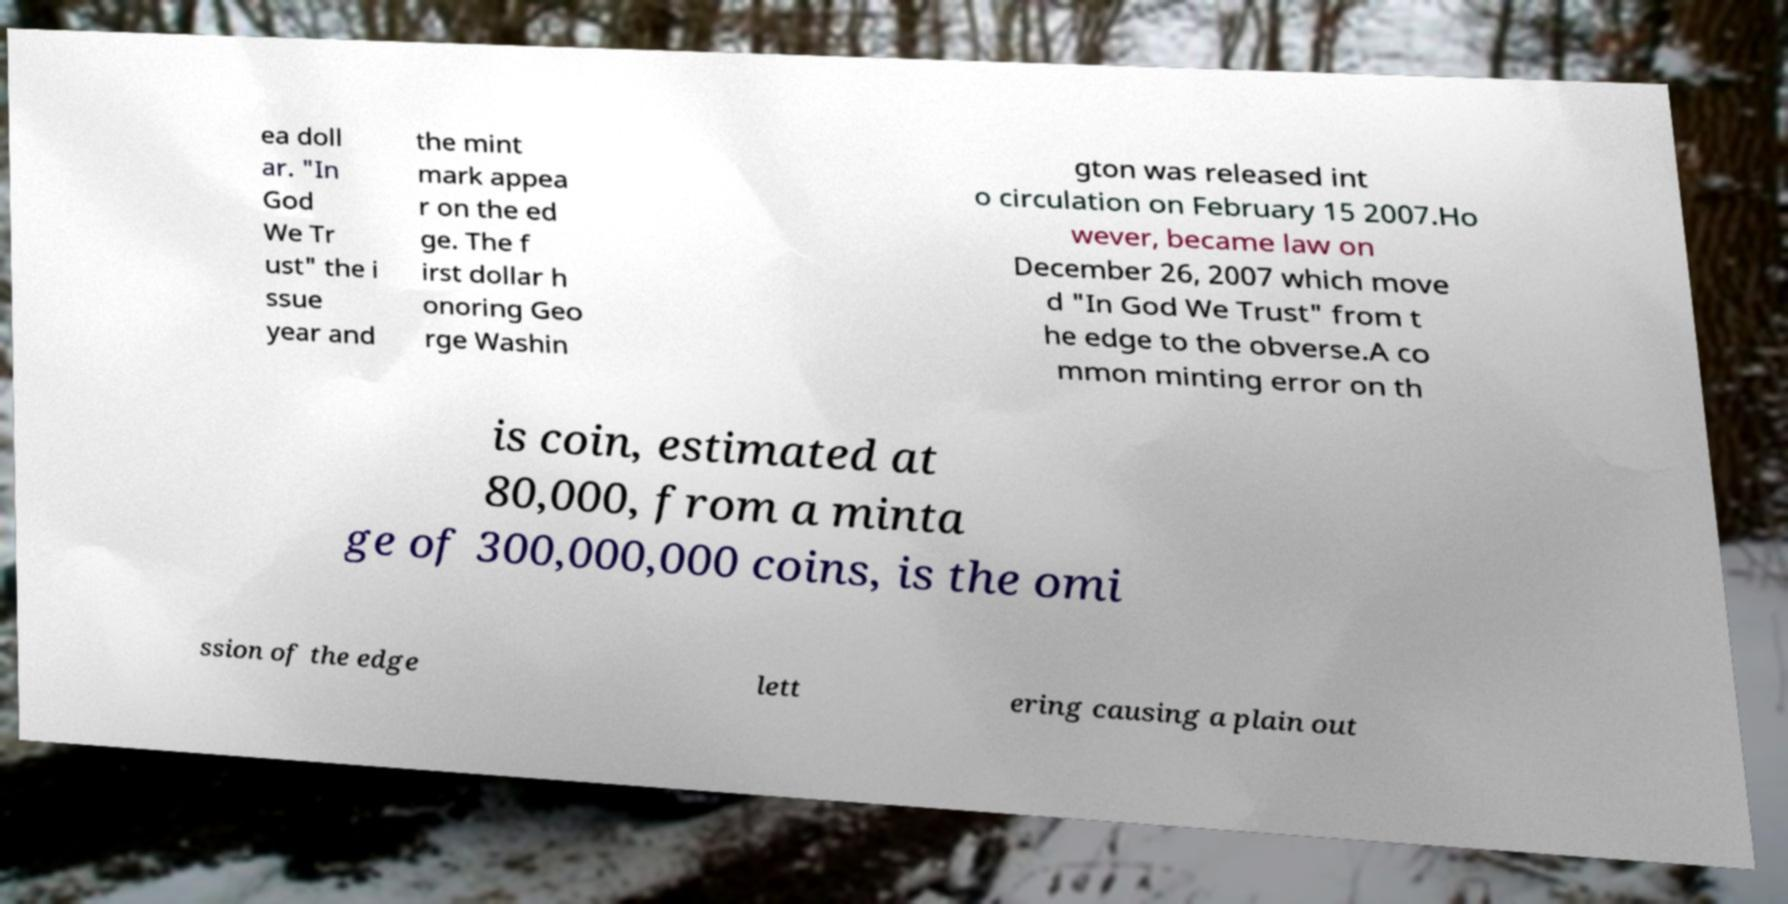Could you assist in decoding the text presented in this image and type it out clearly? ea doll ar. "In God We Tr ust" the i ssue year and the mint mark appea r on the ed ge. The f irst dollar h onoring Geo rge Washin gton was released int o circulation on February 15 2007.Ho wever, became law on December 26, 2007 which move d "In God We Trust" from t he edge to the obverse.A co mmon minting error on th is coin, estimated at 80,000, from a minta ge of 300,000,000 coins, is the omi ssion of the edge lett ering causing a plain out 